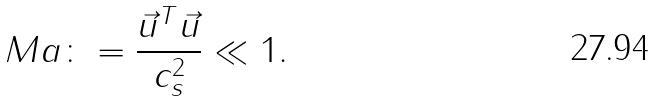Convert formula to latex. <formula><loc_0><loc_0><loc_500><loc_500>M a \colon = \frac { \vec { u } ^ { T } \vec { u } } { c _ { s } ^ { 2 } } \ll 1 .</formula> 